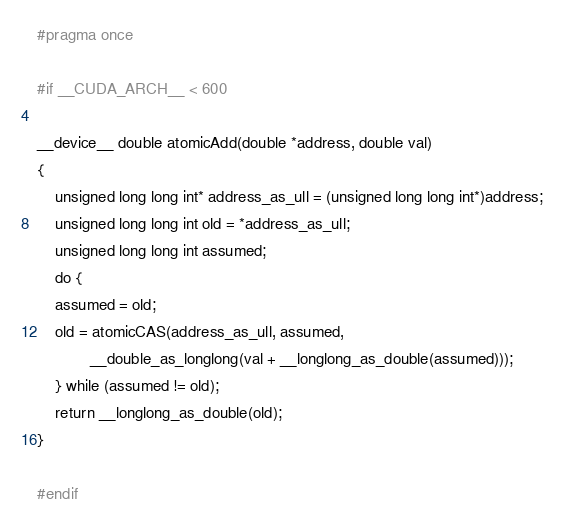<code> <loc_0><loc_0><loc_500><loc_500><_Cuda_>#pragma once

#if __CUDA_ARCH__ < 600

__device__ double atomicAdd(double *address, double val)
{
    unsigned long long int* address_as_ull = (unsigned long long int*)address;
    unsigned long long int old = *address_as_ull;
    unsigned long long int assumed;
    do {
	assumed = old;
	old = atomicCAS(address_as_ull, assumed,
			__double_as_longlong(val + __longlong_as_double(assumed)));
    } while (assumed != old);
    return __longlong_as_double(old);
}

#endif
</code> 